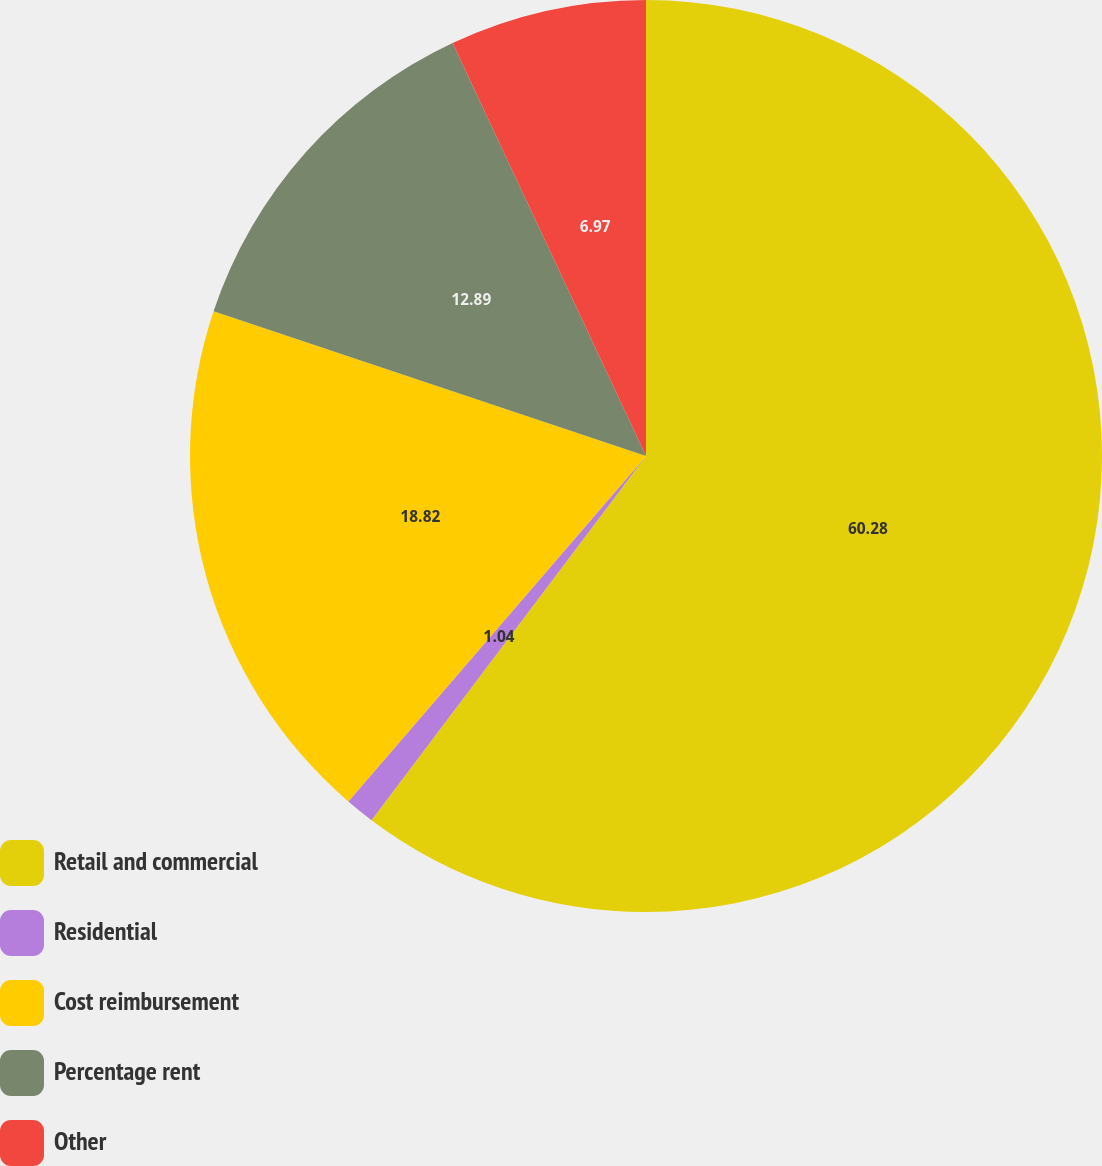Convert chart to OTSL. <chart><loc_0><loc_0><loc_500><loc_500><pie_chart><fcel>Retail and commercial<fcel>Residential<fcel>Cost reimbursement<fcel>Percentage rent<fcel>Other<nl><fcel>60.28%<fcel>1.04%<fcel>18.82%<fcel>12.89%<fcel>6.97%<nl></chart> 